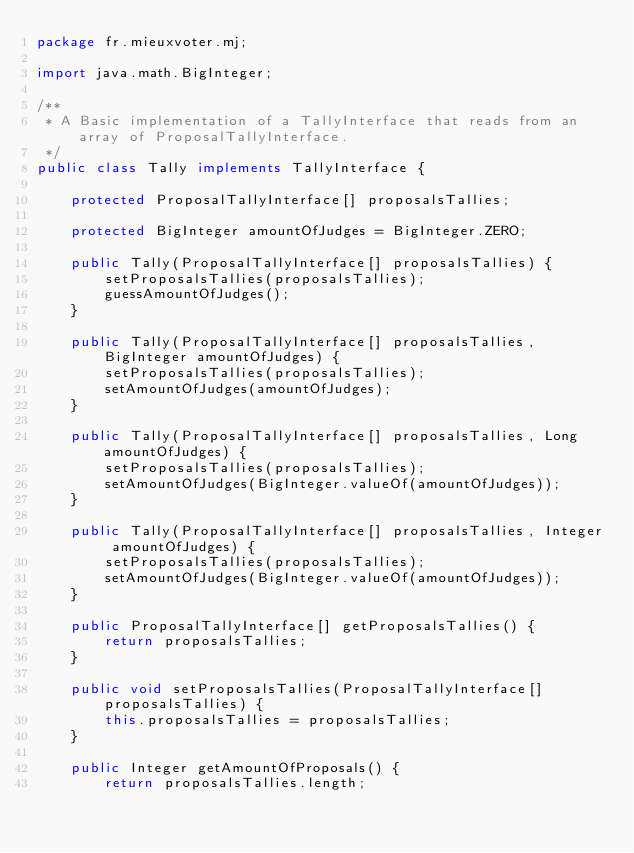Convert code to text. <code><loc_0><loc_0><loc_500><loc_500><_Java_>package fr.mieuxvoter.mj;

import java.math.BigInteger;

/**
 * A Basic implementation of a TallyInterface that reads from an array of ProposalTallyInterface.
 */
public class Tally implements TallyInterface {

    protected ProposalTallyInterface[] proposalsTallies;

    protected BigInteger amountOfJudges = BigInteger.ZERO;

    public Tally(ProposalTallyInterface[] proposalsTallies) {
        setProposalsTallies(proposalsTallies);
        guessAmountOfJudges();
    }

    public Tally(ProposalTallyInterface[] proposalsTallies, BigInteger amountOfJudges) {
        setProposalsTallies(proposalsTallies);
        setAmountOfJudges(amountOfJudges);
    }

    public Tally(ProposalTallyInterface[] proposalsTallies, Long amountOfJudges) {
        setProposalsTallies(proposalsTallies);
        setAmountOfJudges(BigInteger.valueOf(amountOfJudges));
    }

    public Tally(ProposalTallyInterface[] proposalsTallies, Integer amountOfJudges) {
        setProposalsTallies(proposalsTallies);
        setAmountOfJudges(BigInteger.valueOf(amountOfJudges));
    }

    public ProposalTallyInterface[] getProposalsTallies() {
        return proposalsTallies;
    }

    public void setProposalsTallies(ProposalTallyInterface[] proposalsTallies) {
        this.proposalsTallies = proposalsTallies;
    }

    public Integer getAmountOfProposals() {
        return proposalsTallies.length;</code> 